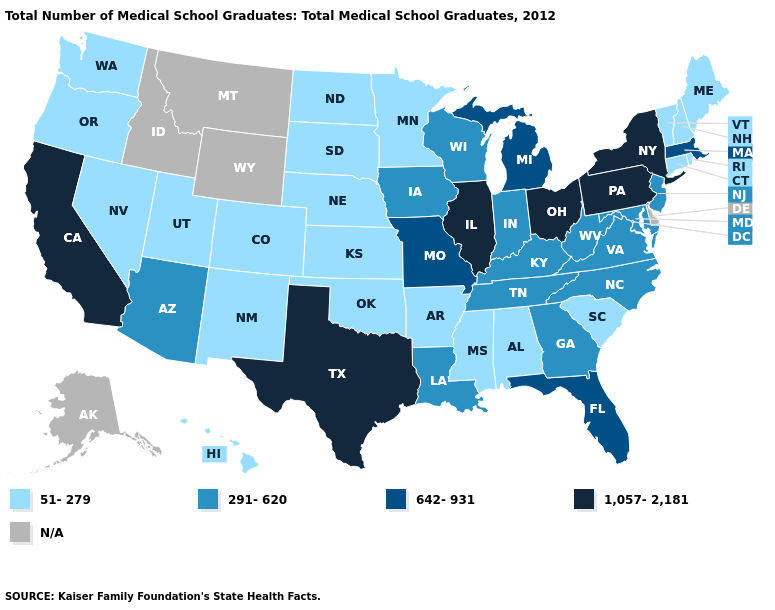What is the highest value in the USA?
Write a very short answer. 1,057-2,181. What is the value of New York?
Concise answer only. 1,057-2,181. Does Utah have the highest value in the West?
Be succinct. No. Does New Jersey have the highest value in the Northeast?
Write a very short answer. No. Name the states that have a value in the range 642-931?
Answer briefly. Florida, Massachusetts, Michigan, Missouri. Name the states that have a value in the range 291-620?
Give a very brief answer. Arizona, Georgia, Indiana, Iowa, Kentucky, Louisiana, Maryland, New Jersey, North Carolina, Tennessee, Virginia, West Virginia, Wisconsin. What is the highest value in the USA?
Answer briefly. 1,057-2,181. Is the legend a continuous bar?
Write a very short answer. No. What is the lowest value in states that border Connecticut?
Be succinct. 51-279. What is the value of Nevada?
Concise answer only. 51-279. Name the states that have a value in the range 642-931?
Write a very short answer. Florida, Massachusetts, Michigan, Missouri. Name the states that have a value in the range 291-620?
Keep it brief. Arizona, Georgia, Indiana, Iowa, Kentucky, Louisiana, Maryland, New Jersey, North Carolina, Tennessee, Virginia, West Virginia, Wisconsin. Which states hav the highest value in the West?
Write a very short answer. California. 